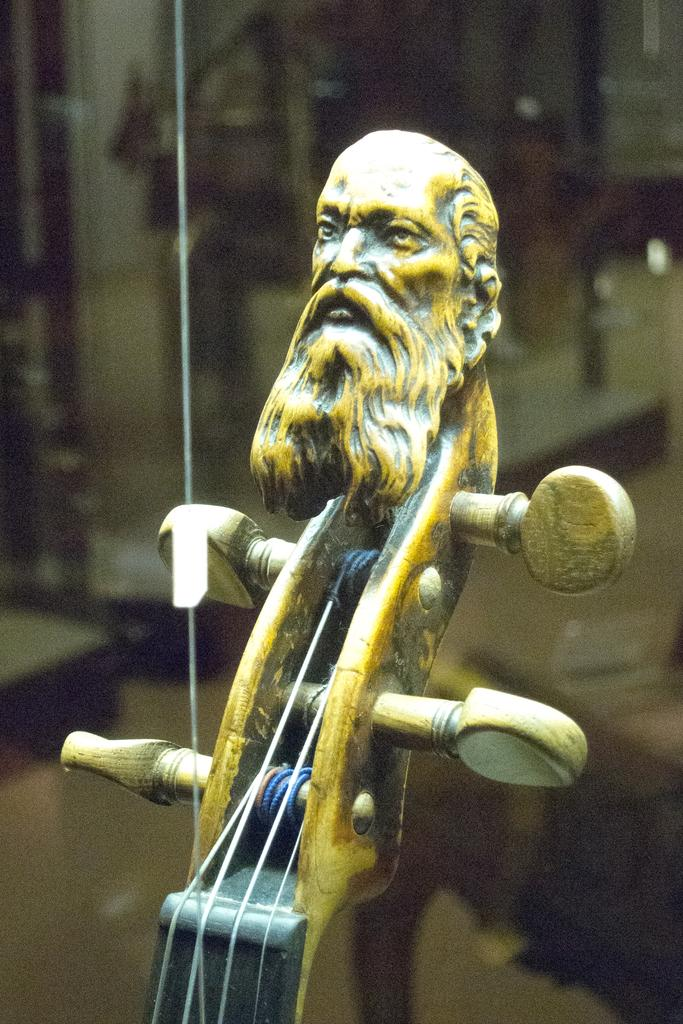What is the main subject of the image? The main subject of the image is an old man sculpture. Can you describe the sculpture's location or context? The sculpture is at the end of a guitar. What type of harbor can be seen in the background of the image? There is no harbor present in the image; it only features an old man sculpture at the end of a guitar. What kind of apparatus is used to shape the old man sculpture? The facts provided do not mention any apparatus used to shape the old man sculpture. 